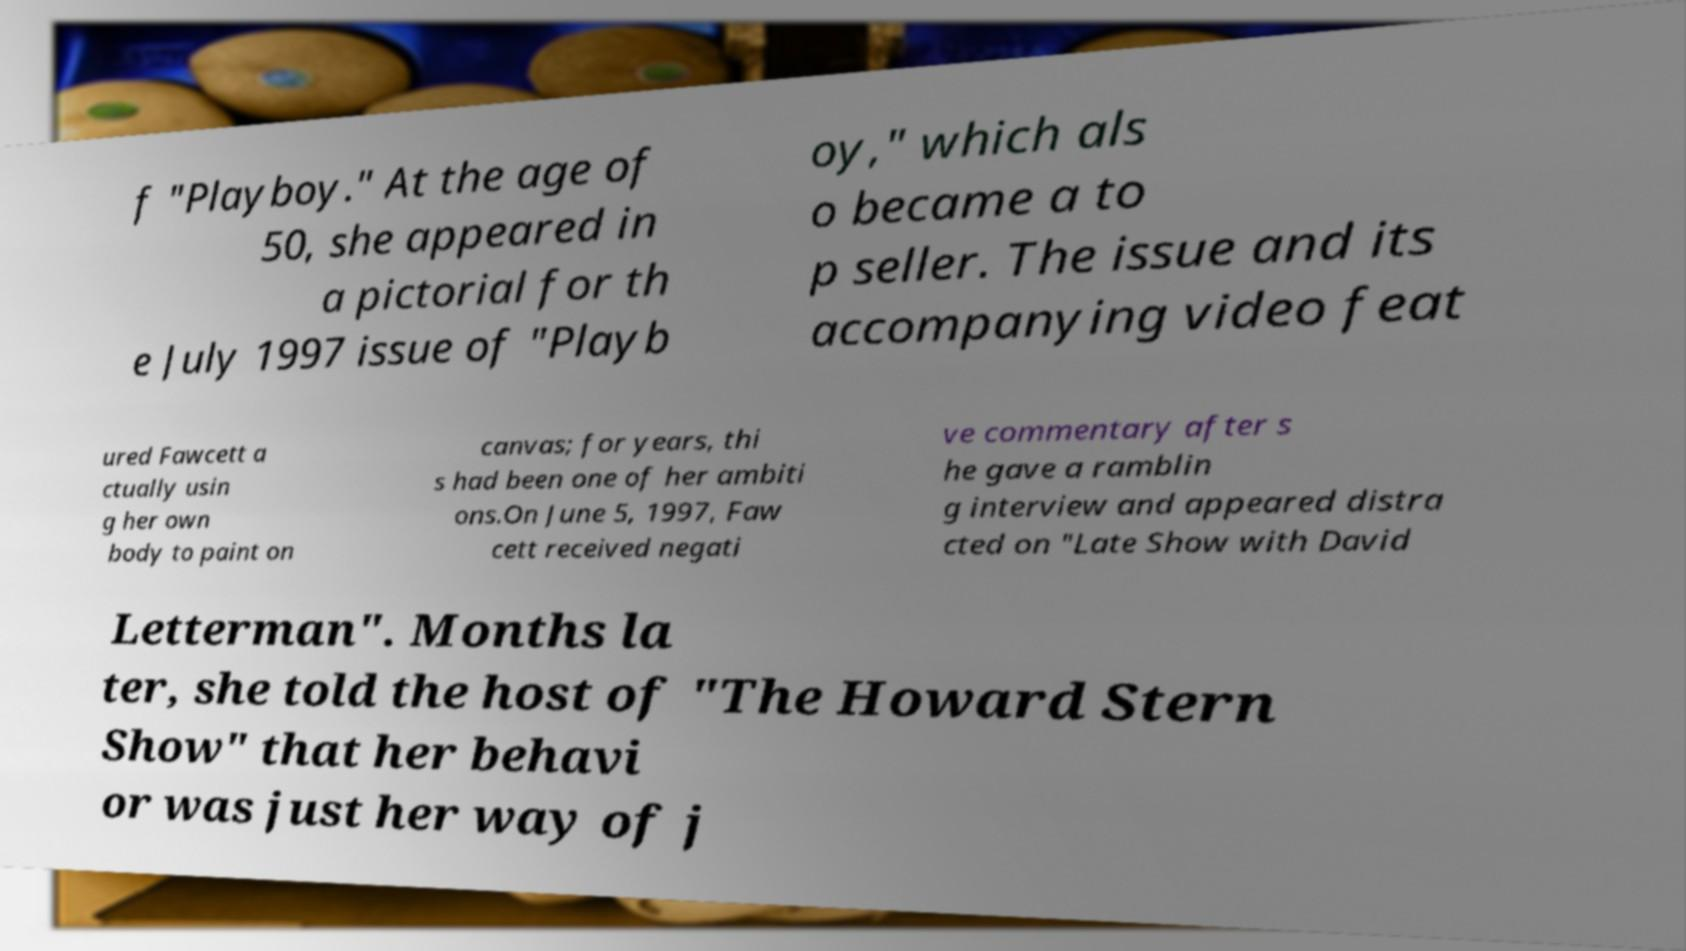Can you read and provide the text displayed in the image?This photo seems to have some interesting text. Can you extract and type it out for me? f "Playboy." At the age of 50, she appeared in a pictorial for th e July 1997 issue of "Playb oy," which als o became a to p seller. The issue and its accompanying video feat ured Fawcett a ctually usin g her own body to paint on canvas; for years, thi s had been one of her ambiti ons.On June 5, 1997, Faw cett received negati ve commentary after s he gave a ramblin g interview and appeared distra cted on "Late Show with David Letterman". Months la ter, she told the host of "The Howard Stern Show" that her behavi or was just her way of j 